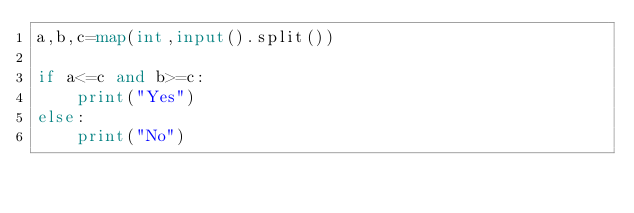<code> <loc_0><loc_0><loc_500><loc_500><_Python_>a,b,c=map(int,input().split())

if a<=c and b>=c:
    print("Yes")
else:
    print("No")</code> 